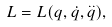Convert formula to latex. <formula><loc_0><loc_0><loc_500><loc_500>L = L ( q , \dot { q } , \overset { . . } { q } ) ,</formula> 